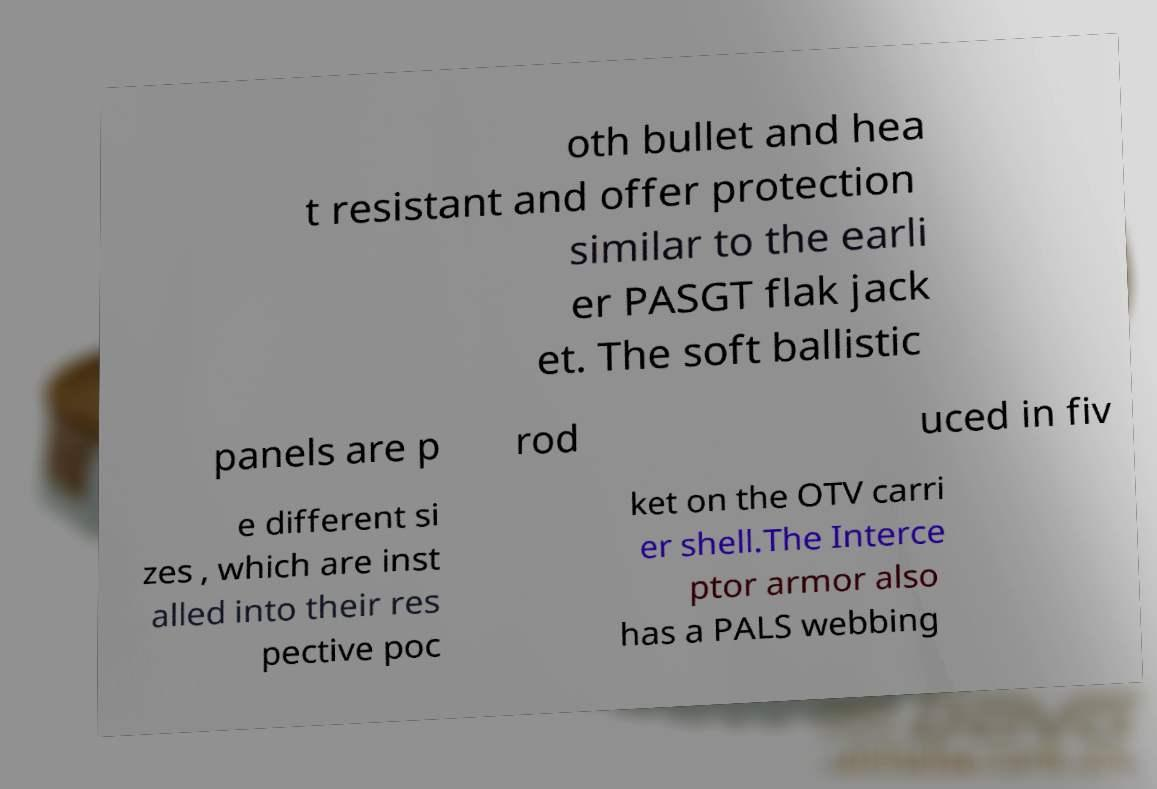Please identify and transcribe the text found in this image. oth bullet and hea t resistant and offer protection similar to the earli er PASGT flak jack et. The soft ballistic panels are p rod uced in fiv e different si zes , which are inst alled into their res pective poc ket on the OTV carri er shell.The Interce ptor armor also has a PALS webbing 